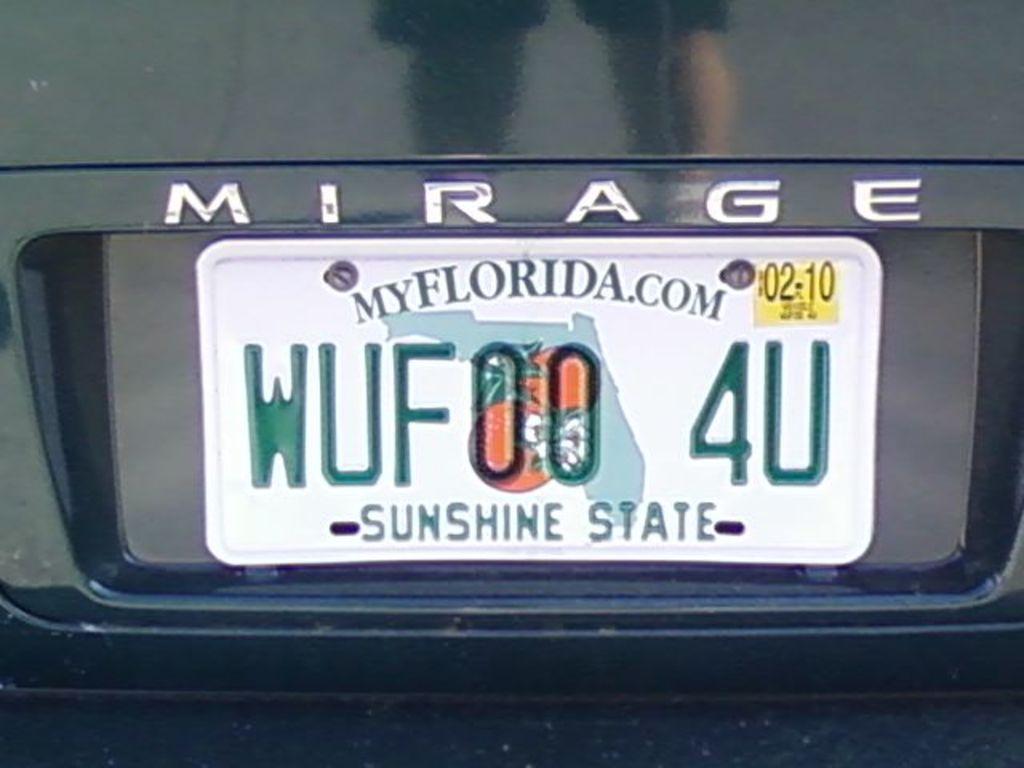What state is this license plate from?
Make the answer very short. Florida. What letter does the license plate end in?
Offer a very short reply. U. 